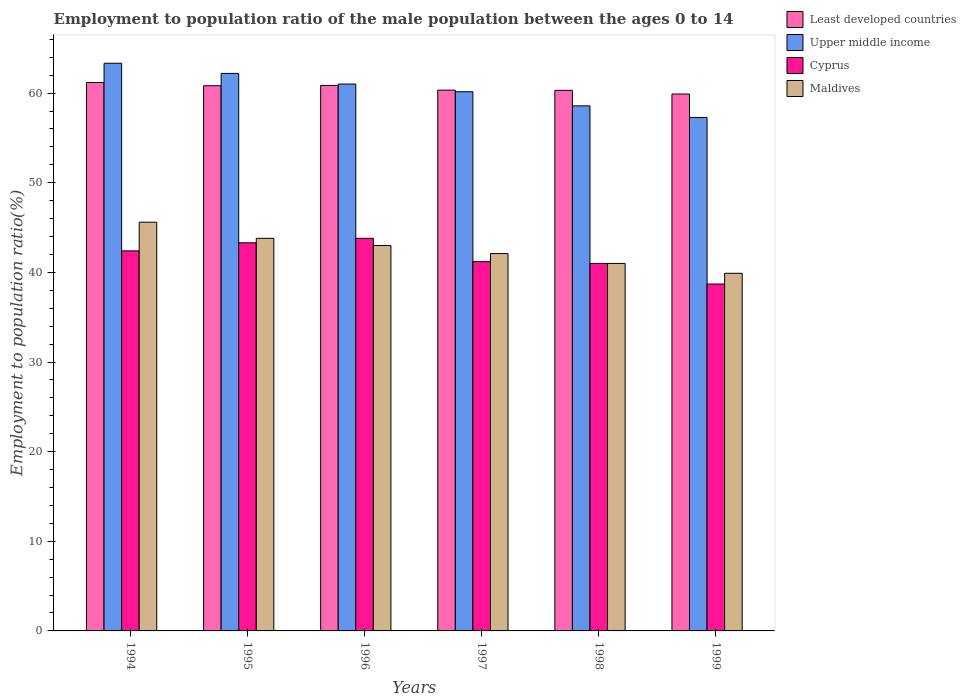How many groups of bars are there?
Provide a succinct answer. 6. How many bars are there on the 6th tick from the right?
Your answer should be compact. 4. What is the label of the 6th group of bars from the left?
Keep it short and to the point. 1999. What is the employment to population ratio in Maldives in 1998?
Ensure brevity in your answer.  41. Across all years, what is the maximum employment to population ratio in Upper middle income?
Offer a terse response. 63.33. Across all years, what is the minimum employment to population ratio in Cyprus?
Your response must be concise. 38.7. In which year was the employment to population ratio in Cyprus minimum?
Offer a very short reply. 1999. What is the total employment to population ratio in Maldives in the graph?
Provide a short and direct response. 255.4. What is the difference between the employment to population ratio in Least developed countries in 1994 and that in 1995?
Provide a short and direct response. 0.36. What is the difference between the employment to population ratio in Upper middle income in 1996 and the employment to population ratio in Least developed countries in 1994?
Offer a very short reply. -0.17. What is the average employment to population ratio in Least developed countries per year?
Provide a short and direct response. 60.57. In the year 1998, what is the difference between the employment to population ratio in Upper middle income and employment to population ratio in Least developed countries?
Your answer should be very brief. -1.73. In how many years, is the employment to population ratio in Least developed countries greater than 54 %?
Your response must be concise. 6. What is the ratio of the employment to population ratio in Upper middle income in 1994 to that in 1999?
Give a very brief answer. 1.11. Is the employment to population ratio in Maldives in 1994 less than that in 1995?
Make the answer very short. No. What is the difference between the highest and the second highest employment to population ratio in Upper middle income?
Give a very brief answer. 1.13. What is the difference between the highest and the lowest employment to population ratio in Upper middle income?
Your answer should be very brief. 6.04. Is the sum of the employment to population ratio in Cyprus in 1994 and 1999 greater than the maximum employment to population ratio in Least developed countries across all years?
Give a very brief answer. Yes. Is it the case that in every year, the sum of the employment to population ratio in Maldives and employment to population ratio in Least developed countries is greater than the sum of employment to population ratio in Upper middle income and employment to population ratio in Cyprus?
Provide a succinct answer. No. What does the 1st bar from the left in 1998 represents?
Ensure brevity in your answer.  Least developed countries. What does the 4th bar from the right in 1999 represents?
Your answer should be compact. Least developed countries. Are all the bars in the graph horizontal?
Offer a terse response. No. How many years are there in the graph?
Provide a succinct answer. 6. Does the graph contain grids?
Give a very brief answer. No. How are the legend labels stacked?
Provide a succinct answer. Vertical. What is the title of the graph?
Give a very brief answer. Employment to population ratio of the male population between the ages 0 to 14. Does "San Marino" appear as one of the legend labels in the graph?
Ensure brevity in your answer.  No. What is the label or title of the X-axis?
Offer a very short reply. Years. What is the Employment to population ratio(%) in Least developed countries in 1994?
Offer a very short reply. 61.18. What is the Employment to population ratio(%) in Upper middle income in 1994?
Give a very brief answer. 63.33. What is the Employment to population ratio(%) in Cyprus in 1994?
Your response must be concise. 42.4. What is the Employment to population ratio(%) of Maldives in 1994?
Your answer should be very brief. 45.6. What is the Employment to population ratio(%) of Least developed countries in 1995?
Offer a terse response. 60.82. What is the Employment to population ratio(%) of Upper middle income in 1995?
Provide a short and direct response. 62.2. What is the Employment to population ratio(%) of Cyprus in 1995?
Provide a short and direct response. 43.3. What is the Employment to population ratio(%) of Maldives in 1995?
Give a very brief answer. 43.8. What is the Employment to population ratio(%) of Least developed countries in 1996?
Your response must be concise. 60.86. What is the Employment to population ratio(%) in Upper middle income in 1996?
Offer a very short reply. 61.01. What is the Employment to population ratio(%) of Cyprus in 1996?
Keep it short and to the point. 43.8. What is the Employment to population ratio(%) of Least developed countries in 1997?
Provide a succinct answer. 60.33. What is the Employment to population ratio(%) of Upper middle income in 1997?
Offer a very short reply. 60.15. What is the Employment to population ratio(%) in Cyprus in 1997?
Offer a terse response. 41.2. What is the Employment to population ratio(%) in Maldives in 1997?
Offer a terse response. 42.1. What is the Employment to population ratio(%) in Least developed countries in 1998?
Your response must be concise. 60.31. What is the Employment to population ratio(%) in Upper middle income in 1998?
Provide a short and direct response. 58.58. What is the Employment to population ratio(%) of Cyprus in 1998?
Your response must be concise. 41. What is the Employment to population ratio(%) in Least developed countries in 1999?
Your response must be concise. 59.9. What is the Employment to population ratio(%) in Upper middle income in 1999?
Keep it short and to the point. 57.29. What is the Employment to population ratio(%) in Cyprus in 1999?
Your answer should be very brief. 38.7. What is the Employment to population ratio(%) in Maldives in 1999?
Offer a terse response. 39.9. Across all years, what is the maximum Employment to population ratio(%) in Least developed countries?
Keep it short and to the point. 61.18. Across all years, what is the maximum Employment to population ratio(%) of Upper middle income?
Offer a terse response. 63.33. Across all years, what is the maximum Employment to population ratio(%) in Cyprus?
Provide a short and direct response. 43.8. Across all years, what is the maximum Employment to population ratio(%) in Maldives?
Your answer should be compact. 45.6. Across all years, what is the minimum Employment to population ratio(%) of Least developed countries?
Offer a terse response. 59.9. Across all years, what is the minimum Employment to population ratio(%) in Upper middle income?
Keep it short and to the point. 57.29. Across all years, what is the minimum Employment to population ratio(%) in Cyprus?
Provide a succinct answer. 38.7. Across all years, what is the minimum Employment to population ratio(%) of Maldives?
Offer a terse response. 39.9. What is the total Employment to population ratio(%) of Least developed countries in the graph?
Provide a succinct answer. 363.41. What is the total Employment to population ratio(%) in Upper middle income in the graph?
Your answer should be compact. 362.56. What is the total Employment to population ratio(%) of Cyprus in the graph?
Your answer should be very brief. 250.4. What is the total Employment to population ratio(%) in Maldives in the graph?
Ensure brevity in your answer.  255.4. What is the difference between the Employment to population ratio(%) in Least developed countries in 1994 and that in 1995?
Make the answer very short. 0.36. What is the difference between the Employment to population ratio(%) in Upper middle income in 1994 and that in 1995?
Your response must be concise. 1.13. What is the difference between the Employment to population ratio(%) in Maldives in 1994 and that in 1995?
Offer a very short reply. 1.8. What is the difference between the Employment to population ratio(%) in Least developed countries in 1994 and that in 1996?
Your answer should be compact. 0.32. What is the difference between the Employment to population ratio(%) of Upper middle income in 1994 and that in 1996?
Provide a succinct answer. 2.32. What is the difference between the Employment to population ratio(%) of Cyprus in 1994 and that in 1996?
Provide a short and direct response. -1.4. What is the difference between the Employment to population ratio(%) of Maldives in 1994 and that in 1996?
Provide a short and direct response. 2.6. What is the difference between the Employment to population ratio(%) in Least developed countries in 1994 and that in 1997?
Offer a terse response. 0.85. What is the difference between the Employment to population ratio(%) in Upper middle income in 1994 and that in 1997?
Ensure brevity in your answer.  3.18. What is the difference between the Employment to population ratio(%) in Least developed countries in 1994 and that in 1998?
Your response must be concise. 0.87. What is the difference between the Employment to population ratio(%) in Upper middle income in 1994 and that in 1998?
Offer a terse response. 4.75. What is the difference between the Employment to population ratio(%) in Cyprus in 1994 and that in 1998?
Make the answer very short. 1.4. What is the difference between the Employment to population ratio(%) of Maldives in 1994 and that in 1998?
Give a very brief answer. 4.6. What is the difference between the Employment to population ratio(%) in Least developed countries in 1994 and that in 1999?
Provide a succinct answer. 1.28. What is the difference between the Employment to population ratio(%) in Upper middle income in 1994 and that in 1999?
Keep it short and to the point. 6.04. What is the difference between the Employment to population ratio(%) in Maldives in 1994 and that in 1999?
Provide a succinct answer. 5.7. What is the difference between the Employment to population ratio(%) in Least developed countries in 1995 and that in 1996?
Your response must be concise. -0.04. What is the difference between the Employment to population ratio(%) of Upper middle income in 1995 and that in 1996?
Give a very brief answer. 1.19. What is the difference between the Employment to population ratio(%) in Cyprus in 1995 and that in 1996?
Make the answer very short. -0.5. What is the difference between the Employment to population ratio(%) of Least developed countries in 1995 and that in 1997?
Your answer should be compact. 0.49. What is the difference between the Employment to population ratio(%) in Upper middle income in 1995 and that in 1997?
Your answer should be compact. 2.05. What is the difference between the Employment to population ratio(%) in Cyprus in 1995 and that in 1997?
Offer a terse response. 2.1. What is the difference between the Employment to population ratio(%) of Least developed countries in 1995 and that in 1998?
Make the answer very short. 0.51. What is the difference between the Employment to population ratio(%) of Upper middle income in 1995 and that in 1998?
Give a very brief answer. 3.62. What is the difference between the Employment to population ratio(%) of Least developed countries in 1995 and that in 1999?
Your response must be concise. 0.92. What is the difference between the Employment to population ratio(%) in Upper middle income in 1995 and that in 1999?
Your answer should be compact. 4.91. What is the difference between the Employment to population ratio(%) in Cyprus in 1995 and that in 1999?
Your answer should be compact. 4.6. What is the difference between the Employment to population ratio(%) in Least developed countries in 1996 and that in 1997?
Make the answer very short. 0.53. What is the difference between the Employment to population ratio(%) in Upper middle income in 1996 and that in 1997?
Provide a short and direct response. 0.86. What is the difference between the Employment to population ratio(%) of Least developed countries in 1996 and that in 1998?
Keep it short and to the point. 0.55. What is the difference between the Employment to population ratio(%) of Upper middle income in 1996 and that in 1998?
Provide a short and direct response. 2.43. What is the difference between the Employment to population ratio(%) in Cyprus in 1996 and that in 1998?
Offer a very short reply. 2.8. What is the difference between the Employment to population ratio(%) of Least developed countries in 1996 and that in 1999?
Ensure brevity in your answer.  0.96. What is the difference between the Employment to population ratio(%) in Upper middle income in 1996 and that in 1999?
Give a very brief answer. 3.73. What is the difference between the Employment to population ratio(%) of Cyprus in 1996 and that in 1999?
Give a very brief answer. 5.1. What is the difference between the Employment to population ratio(%) in Maldives in 1996 and that in 1999?
Give a very brief answer. 3.1. What is the difference between the Employment to population ratio(%) of Least developed countries in 1997 and that in 1998?
Your answer should be compact. 0.02. What is the difference between the Employment to population ratio(%) in Upper middle income in 1997 and that in 1998?
Offer a terse response. 1.57. What is the difference between the Employment to population ratio(%) in Maldives in 1997 and that in 1998?
Your response must be concise. 1.1. What is the difference between the Employment to population ratio(%) in Least developed countries in 1997 and that in 1999?
Provide a succinct answer. 0.43. What is the difference between the Employment to population ratio(%) of Upper middle income in 1997 and that in 1999?
Make the answer very short. 2.86. What is the difference between the Employment to population ratio(%) of Maldives in 1997 and that in 1999?
Provide a succinct answer. 2.2. What is the difference between the Employment to population ratio(%) in Least developed countries in 1998 and that in 1999?
Make the answer very short. 0.41. What is the difference between the Employment to population ratio(%) in Upper middle income in 1998 and that in 1999?
Offer a terse response. 1.29. What is the difference between the Employment to population ratio(%) in Maldives in 1998 and that in 1999?
Provide a succinct answer. 1.1. What is the difference between the Employment to population ratio(%) of Least developed countries in 1994 and the Employment to population ratio(%) of Upper middle income in 1995?
Offer a very short reply. -1.02. What is the difference between the Employment to population ratio(%) of Least developed countries in 1994 and the Employment to population ratio(%) of Cyprus in 1995?
Offer a terse response. 17.88. What is the difference between the Employment to population ratio(%) in Least developed countries in 1994 and the Employment to population ratio(%) in Maldives in 1995?
Provide a succinct answer. 17.38. What is the difference between the Employment to population ratio(%) of Upper middle income in 1994 and the Employment to population ratio(%) of Cyprus in 1995?
Provide a succinct answer. 20.03. What is the difference between the Employment to population ratio(%) of Upper middle income in 1994 and the Employment to population ratio(%) of Maldives in 1995?
Your answer should be very brief. 19.53. What is the difference between the Employment to population ratio(%) of Least developed countries in 1994 and the Employment to population ratio(%) of Cyprus in 1996?
Your answer should be compact. 17.38. What is the difference between the Employment to population ratio(%) in Least developed countries in 1994 and the Employment to population ratio(%) in Maldives in 1996?
Your response must be concise. 18.18. What is the difference between the Employment to population ratio(%) of Upper middle income in 1994 and the Employment to population ratio(%) of Cyprus in 1996?
Give a very brief answer. 19.53. What is the difference between the Employment to population ratio(%) of Upper middle income in 1994 and the Employment to population ratio(%) of Maldives in 1996?
Keep it short and to the point. 20.33. What is the difference between the Employment to population ratio(%) in Least developed countries in 1994 and the Employment to population ratio(%) in Upper middle income in 1997?
Make the answer very short. 1.03. What is the difference between the Employment to population ratio(%) of Least developed countries in 1994 and the Employment to population ratio(%) of Cyprus in 1997?
Offer a very short reply. 19.98. What is the difference between the Employment to population ratio(%) in Least developed countries in 1994 and the Employment to population ratio(%) in Maldives in 1997?
Your answer should be very brief. 19.08. What is the difference between the Employment to population ratio(%) in Upper middle income in 1994 and the Employment to population ratio(%) in Cyprus in 1997?
Give a very brief answer. 22.13. What is the difference between the Employment to population ratio(%) of Upper middle income in 1994 and the Employment to population ratio(%) of Maldives in 1997?
Your answer should be very brief. 21.23. What is the difference between the Employment to population ratio(%) in Least developed countries in 1994 and the Employment to population ratio(%) in Upper middle income in 1998?
Make the answer very short. 2.6. What is the difference between the Employment to population ratio(%) in Least developed countries in 1994 and the Employment to population ratio(%) in Cyprus in 1998?
Make the answer very short. 20.18. What is the difference between the Employment to population ratio(%) of Least developed countries in 1994 and the Employment to population ratio(%) of Maldives in 1998?
Offer a very short reply. 20.18. What is the difference between the Employment to population ratio(%) in Upper middle income in 1994 and the Employment to population ratio(%) in Cyprus in 1998?
Provide a succinct answer. 22.33. What is the difference between the Employment to population ratio(%) in Upper middle income in 1994 and the Employment to population ratio(%) in Maldives in 1998?
Your answer should be very brief. 22.33. What is the difference between the Employment to population ratio(%) in Least developed countries in 1994 and the Employment to population ratio(%) in Upper middle income in 1999?
Offer a terse response. 3.89. What is the difference between the Employment to population ratio(%) in Least developed countries in 1994 and the Employment to population ratio(%) in Cyprus in 1999?
Give a very brief answer. 22.48. What is the difference between the Employment to population ratio(%) in Least developed countries in 1994 and the Employment to population ratio(%) in Maldives in 1999?
Provide a short and direct response. 21.28. What is the difference between the Employment to population ratio(%) in Upper middle income in 1994 and the Employment to population ratio(%) in Cyprus in 1999?
Offer a terse response. 24.63. What is the difference between the Employment to population ratio(%) in Upper middle income in 1994 and the Employment to population ratio(%) in Maldives in 1999?
Ensure brevity in your answer.  23.43. What is the difference between the Employment to population ratio(%) in Least developed countries in 1995 and the Employment to population ratio(%) in Upper middle income in 1996?
Give a very brief answer. -0.19. What is the difference between the Employment to population ratio(%) of Least developed countries in 1995 and the Employment to population ratio(%) of Cyprus in 1996?
Your answer should be compact. 17.02. What is the difference between the Employment to population ratio(%) of Least developed countries in 1995 and the Employment to population ratio(%) of Maldives in 1996?
Your answer should be very brief. 17.82. What is the difference between the Employment to population ratio(%) of Upper middle income in 1995 and the Employment to population ratio(%) of Cyprus in 1996?
Your response must be concise. 18.4. What is the difference between the Employment to population ratio(%) in Upper middle income in 1995 and the Employment to population ratio(%) in Maldives in 1996?
Your response must be concise. 19.2. What is the difference between the Employment to population ratio(%) in Cyprus in 1995 and the Employment to population ratio(%) in Maldives in 1996?
Offer a terse response. 0.3. What is the difference between the Employment to population ratio(%) of Least developed countries in 1995 and the Employment to population ratio(%) of Upper middle income in 1997?
Your answer should be very brief. 0.67. What is the difference between the Employment to population ratio(%) of Least developed countries in 1995 and the Employment to population ratio(%) of Cyprus in 1997?
Give a very brief answer. 19.62. What is the difference between the Employment to population ratio(%) in Least developed countries in 1995 and the Employment to population ratio(%) in Maldives in 1997?
Ensure brevity in your answer.  18.72. What is the difference between the Employment to population ratio(%) in Upper middle income in 1995 and the Employment to population ratio(%) in Cyprus in 1997?
Give a very brief answer. 21. What is the difference between the Employment to population ratio(%) in Upper middle income in 1995 and the Employment to population ratio(%) in Maldives in 1997?
Make the answer very short. 20.1. What is the difference between the Employment to population ratio(%) of Least developed countries in 1995 and the Employment to population ratio(%) of Upper middle income in 1998?
Your answer should be compact. 2.24. What is the difference between the Employment to population ratio(%) in Least developed countries in 1995 and the Employment to population ratio(%) in Cyprus in 1998?
Provide a short and direct response. 19.82. What is the difference between the Employment to population ratio(%) in Least developed countries in 1995 and the Employment to population ratio(%) in Maldives in 1998?
Offer a very short reply. 19.82. What is the difference between the Employment to population ratio(%) in Upper middle income in 1995 and the Employment to population ratio(%) in Cyprus in 1998?
Keep it short and to the point. 21.2. What is the difference between the Employment to population ratio(%) of Upper middle income in 1995 and the Employment to population ratio(%) of Maldives in 1998?
Provide a succinct answer. 21.2. What is the difference between the Employment to population ratio(%) in Cyprus in 1995 and the Employment to population ratio(%) in Maldives in 1998?
Offer a terse response. 2.3. What is the difference between the Employment to population ratio(%) of Least developed countries in 1995 and the Employment to population ratio(%) of Upper middle income in 1999?
Make the answer very short. 3.54. What is the difference between the Employment to population ratio(%) in Least developed countries in 1995 and the Employment to population ratio(%) in Cyprus in 1999?
Provide a succinct answer. 22.12. What is the difference between the Employment to population ratio(%) in Least developed countries in 1995 and the Employment to population ratio(%) in Maldives in 1999?
Give a very brief answer. 20.92. What is the difference between the Employment to population ratio(%) of Upper middle income in 1995 and the Employment to population ratio(%) of Cyprus in 1999?
Give a very brief answer. 23.5. What is the difference between the Employment to population ratio(%) in Upper middle income in 1995 and the Employment to population ratio(%) in Maldives in 1999?
Make the answer very short. 22.3. What is the difference between the Employment to population ratio(%) of Least developed countries in 1996 and the Employment to population ratio(%) of Upper middle income in 1997?
Offer a very short reply. 0.71. What is the difference between the Employment to population ratio(%) in Least developed countries in 1996 and the Employment to population ratio(%) in Cyprus in 1997?
Make the answer very short. 19.66. What is the difference between the Employment to population ratio(%) in Least developed countries in 1996 and the Employment to population ratio(%) in Maldives in 1997?
Your response must be concise. 18.76. What is the difference between the Employment to population ratio(%) in Upper middle income in 1996 and the Employment to population ratio(%) in Cyprus in 1997?
Your answer should be very brief. 19.81. What is the difference between the Employment to population ratio(%) in Upper middle income in 1996 and the Employment to population ratio(%) in Maldives in 1997?
Your response must be concise. 18.91. What is the difference between the Employment to population ratio(%) of Cyprus in 1996 and the Employment to population ratio(%) of Maldives in 1997?
Provide a succinct answer. 1.7. What is the difference between the Employment to population ratio(%) in Least developed countries in 1996 and the Employment to population ratio(%) in Upper middle income in 1998?
Give a very brief answer. 2.28. What is the difference between the Employment to population ratio(%) in Least developed countries in 1996 and the Employment to population ratio(%) in Cyprus in 1998?
Ensure brevity in your answer.  19.86. What is the difference between the Employment to population ratio(%) of Least developed countries in 1996 and the Employment to population ratio(%) of Maldives in 1998?
Your answer should be compact. 19.86. What is the difference between the Employment to population ratio(%) in Upper middle income in 1996 and the Employment to population ratio(%) in Cyprus in 1998?
Offer a terse response. 20.01. What is the difference between the Employment to population ratio(%) in Upper middle income in 1996 and the Employment to population ratio(%) in Maldives in 1998?
Offer a very short reply. 20.01. What is the difference between the Employment to population ratio(%) of Least developed countries in 1996 and the Employment to population ratio(%) of Upper middle income in 1999?
Your answer should be very brief. 3.57. What is the difference between the Employment to population ratio(%) in Least developed countries in 1996 and the Employment to population ratio(%) in Cyprus in 1999?
Offer a very short reply. 22.16. What is the difference between the Employment to population ratio(%) in Least developed countries in 1996 and the Employment to population ratio(%) in Maldives in 1999?
Provide a short and direct response. 20.96. What is the difference between the Employment to population ratio(%) of Upper middle income in 1996 and the Employment to population ratio(%) of Cyprus in 1999?
Your answer should be very brief. 22.31. What is the difference between the Employment to population ratio(%) in Upper middle income in 1996 and the Employment to population ratio(%) in Maldives in 1999?
Give a very brief answer. 21.11. What is the difference between the Employment to population ratio(%) of Least developed countries in 1997 and the Employment to population ratio(%) of Upper middle income in 1998?
Provide a short and direct response. 1.75. What is the difference between the Employment to population ratio(%) of Least developed countries in 1997 and the Employment to population ratio(%) of Cyprus in 1998?
Your response must be concise. 19.33. What is the difference between the Employment to population ratio(%) in Least developed countries in 1997 and the Employment to population ratio(%) in Maldives in 1998?
Make the answer very short. 19.33. What is the difference between the Employment to population ratio(%) in Upper middle income in 1997 and the Employment to population ratio(%) in Cyprus in 1998?
Provide a succinct answer. 19.15. What is the difference between the Employment to population ratio(%) in Upper middle income in 1997 and the Employment to population ratio(%) in Maldives in 1998?
Provide a succinct answer. 19.15. What is the difference between the Employment to population ratio(%) of Cyprus in 1997 and the Employment to population ratio(%) of Maldives in 1998?
Your answer should be compact. 0.2. What is the difference between the Employment to population ratio(%) in Least developed countries in 1997 and the Employment to population ratio(%) in Upper middle income in 1999?
Your answer should be compact. 3.05. What is the difference between the Employment to population ratio(%) of Least developed countries in 1997 and the Employment to population ratio(%) of Cyprus in 1999?
Your answer should be very brief. 21.63. What is the difference between the Employment to population ratio(%) in Least developed countries in 1997 and the Employment to population ratio(%) in Maldives in 1999?
Keep it short and to the point. 20.43. What is the difference between the Employment to population ratio(%) in Upper middle income in 1997 and the Employment to population ratio(%) in Cyprus in 1999?
Give a very brief answer. 21.45. What is the difference between the Employment to population ratio(%) in Upper middle income in 1997 and the Employment to population ratio(%) in Maldives in 1999?
Provide a succinct answer. 20.25. What is the difference between the Employment to population ratio(%) in Cyprus in 1997 and the Employment to population ratio(%) in Maldives in 1999?
Keep it short and to the point. 1.3. What is the difference between the Employment to population ratio(%) in Least developed countries in 1998 and the Employment to population ratio(%) in Upper middle income in 1999?
Your response must be concise. 3.02. What is the difference between the Employment to population ratio(%) of Least developed countries in 1998 and the Employment to population ratio(%) of Cyprus in 1999?
Offer a very short reply. 21.61. What is the difference between the Employment to population ratio(%) in Least developed countries in 1998 and the Employment to population ratio(%) in Maldives in 1999?
Make the answer very short. 20.41. What is the difference between the Employment to population ratio(%) in Upper middle income in 1998 and the Employment to population ratio(%) in Cyprus in 1999?
Make the answer very short. 19.88. What is the difference between the Employment to population ratio(%) in Upper middle income in 1998 and the Employment to population ratio(%) in Maldives in 1999?
Offer a very short reply. 18.68. What is the difference between the Employment to population ratio(%) of Cyprus in 1998 and the Employment to population ratio(%) of Maldives in 1999?
Provide a short and direct response. 1.1. What is the average Employment to population ratio(%) of Least developed countries per year?
Give a very brief answer. 60.57. What is the average Employment to population ratio(%) in Upper middle income per year?
Offer a very short reply. 60.43. What is the average Employment to population ratio(%) of Cyprus per year?
Keep it short and to the point. 41.73. What is the average Employment to population ratio(%) of Maldives per year?
Your answer should be compact. 42.57. In the year 1994, what is the difference between the Employment to population ratio(%) of Least developed countries and Employment to population ratio(%) of Upper middle income?
Your response must be concise. -2.15. In the year 1994, what is the difference between the Employment to population ratio(%) of Least developed countries and Employment to population ratio(%) of Cyprus?
Offer a terse response. 18.78. In the year 1994, what is the difference between the Employment to population ratio(%) in Least developed countries and Employment to population ratio(%) in Maldives?
Your answer should be compact. 15.58. In the year 1994, what is the difference between the Employment to population ratio(%) of Upper middle income and Employment to population ratio(%) of Cyprus?
Provide a succinct answer. 20.93. In the year 1994, what is the difference between the Employment to population ratio(%) in Upper middle income and Employment to population ratio(%) in Maldives?
Make the answer very short. 17.73. In the year 1994, what is the difference between the Employment to population ratio(%) in Cyprus and Employment to population ratio(%) in Maldives?
Offer a terse response. -3.2. In the year 1995, what is the difference between the Employment to population ratio(%) of Least developed countries and Employment to population ratio(%) of Upper middle income?
Ensure brevity in your answer.  -1.38. In the year 1995, what is the difference between the Employment to population ratio(%) in Least developed countries and Employment to population ratio(%) in Cyprus?
Your response must be concise. 17.52. In the year 1995, what is the difference between the Employment to population ratio(%) in Least developed countries and Employment to population ratio(%) in Maldives?
Ensure brevity in your answer.  17.02. In the year 1995, what is the difference between the Employment to population ratio(%) in Upper middle income and Employment to population ratio(%) in Cyprus?
Keep it short and to the point. 18.9. In the year 1995, what is the difference between the Employment to population ratio(%) in Upper middle income and Employment to population ratio(%) in Maldives?
Keep it short and to the point. 18.4. In the year 1995, what is the difference between the Employment to population ratio(%) in Cyprus and Employment to population ratio(%) in Maldives?
Your response must be concise. -0.5. In the year 1996, what is the difference between the Employment to population ratio(%) of Least developed countries and Employment to population ratio(%) of Upper middle income?
Provide a succinct answer. -0.15. In the year 1996, what is the difference between the Employment to population ratio(%) of Least developed countries and Employment to population ratio(%) of Cyprus?
Provide a short and direct response. 17.06. In the year 1996, what is the difference between the Employment to population ratio(%) of Least developed countries and Employment to population ratio(%) of Maldives?
Keep it short and to the point. 17.86. In the year 1996, what is the difference between the Employment to population ratio(%) in Upper middle income and Employment to population ratio(%) in Cyprus?
Ensure brevity in your answer.  17.21. In the year 1996, what is the difference between the Employment to population ratio(%) in Upper middle income and Employment to population ratio(%) in Maldives?
Keep it short and to the point. 18.01. In the year 1996, what is the difference between the Employment to population ratio(%) in Cyprus and Employment to population ratio(%) in Maldives?
Provide a short and direct response. 0.8. In the year 1997, what is the difference between the Employment to population ratio(%) in Least developed countries and Employment to population ratio(%) in Upper middle income?
Your response must be concise. 0.18. In the year 1997, what is the difference between the Employment to population ratio(%) in Least developed countries and Employment to population ratio(%) in Cyprus?
Provide a short and direct response. 19.13. In the year 1997, what is the difference between the Employment to population ratio(%) in Least developed countries and Employment to population ratio(%) in Maldives?
Your response must be concise. 18.23. In the year 1997, what is the difference between the Employment to population ratio(%) of Upper middle income and Employment to population ratio(%) of Cyprus?
Give a very brief answer. 18.95. In the year 1997, what is the difference between the Employment to population ratio(%) of Upper middle income and Employment to population ratio(%) of Maldives?
Offer a terse response. 18.05. In the year 1997, what is the difference between the Employment to population ratio(%) in Cyprus and Employment to population ratio(%) in Maldives?
Keep it short and to the point. -0.9. In the year 1998, what is the difference between the Employment to population ratio(%) of Least developed countries and Employment to population ratio(%) of Upper middle income?
Your answer should be compact. 1.73. In the year 1998, what is the difference between the Employment to population ratio(%) in Least developed countries and Employment to population ratio(%) in Cyprus?
Your answer should be very brief. 19.31. In the year 1998, what is the difference between the Employment to population ratio(%) in Least developed countries and Employment to population ratio(%) in Maldives?
Provide a succinct answer. 19.31. In the year 1998, what is the difference between the Employment to population ratio(%) of Upper middle income and Employment to population ratio(%) of Cyprus?
Provide a short and direct response. 17.58. In the year 1998, what is the difference between the Employment to population ratio(%) of Upper middle income and Employment to population ratio(%) of Maldives?
Make the answer very short. 17.58. In the year 1998, what is the difference between the Employment to population ratio(%) of Cyprus and Employment to population ratio(%) of Maldives?
Ensure brevity in your answer.  0. In the year 1999, what is the difference between the Employment to population ratio(%) of Least developed countries and Employment to population ratio(%) of Upper middle income?
Keep it short and to the point. 2.61. In the year 1999, what is the difference between the Employment to population ratio(%) of Least developed countries and Employment to population ratio(%) of Cyprus?
Make the answer very short. 21.2. In the year 1999, what is the difference between the Employment to population ratio(%) in Least developed countries and Employment to population ratio(%) in Maldives?
Ensure brevity in your answer.  20. In the year 1999, what is the difference between the Employment to population ratio(%) in Upper middle income and Employment to population ratio(%) in Cyprus?
Offer a terse response. 18.59. In the year 1999, what is the difference between the Employment to population ratio(%) of Upper middle income and Employment to population ratio(%) of Maldives?
Keep it short and to the point. 17.39. What is the ratio of the Employment to population ratio(%) in Least developed countries in 1994 to that in 1995?
Your answer should be compact. 1.01. What is the ratio of the Employment to population ratio(%) in Upper middle income in 1994 to that in 1995?
Your response must be concise. 1.02. What is the ratio of the Employment to population ratio(%) in Cyprus in 1994 to that in 1995?
Offer a terse response. 0.98. What is the ratio of the Employment to population ratio(%) in Maldives in 1994 to that in 1995?
Your response must be concise. 1.04. What is the ratio of the Employment to population ratio(%) of Upper middle income in 1994 to that in 1996?
Give a very brief answer. 1.04. What is the ratio of the Employment to population ratio(%) in Cyprus in 1994 to that in 1996?
Ensure brevity in your answer.  0.97. What is the ratio of the Employment to population ratio(%) of Maldives in 1994 to that in 1996?
Provide a short and direct response. 1.06. What is the ratio of the Employment to population ratio(%) in Upper middle income in 1994 to that in 1997?
Your answer should be compact. 1.05. What is the ratio of the Employment to population ratio(%) in Cyprus in 1994 to that in 1997?
Provide a succinct answer. 1.03. What is the ratio of the Employment to population ratio(%) of Maldives in 1994 to that in 1997?
Your answer should be very brief. 1.08. What is the ratio of the Employment to population ratio(%) in Least developed countries in 1994 to that in 1998?
Provide a succinct answer. 1.01. What is the ratio of the Employment to population ratio(%) in Upper middle income in 1994 to that in 1998?
Ensure brevity in your answer.  1.08. What is the ratio of the Employment to population ratio(%) of Cyprus in 1994 to that in 1998?
Offer a very short reply. 1.03. What is the ratio of the Employment to population ratio(%) in Maldives in 1994 to that in 1998?
Make the answer very short. 1.11. What is the ratio of the Employment to population ratio(%) of Least developed countries in 1994 to that in 1999?
Your response must be concise. 1.02. What is the ratio of the Employment to population ratio(%) in Upper middle income in 1994 to that in 1999?
Ensure brevity in your answer.  1.11. What is the ratio of the Employment to population ratio(%) in Cyprus in 1994 to that in 1999?
Your answer should be compact. 1.1. What is the ratio of the Employment to population ratio(%) of Maldives in 1994 to that in 1999?
Make the answer very short. 1.14. What is the ratio of the Employment to population ratio(%) of Least developed countries in 1995 to that in 1996?
Provide a short and direct response. 1. What is the ratio of the Employment to population ratio(%) of Upper middle income in 1995 to that in 1996?
Make the answer very short. 1.02. What is the ratio of the Employment to population ratio(%) of Maldives in 1995 to that in 1996?
Give a very brief answer. 1.02. What is the ratio of the Employment to population ratio(%) of Upper middle income in 1995 to that in 1997?
Your response must be concise. 1.03. What is the ratio of the Employment to population ratio(%) in Cyprus in 1995 to that in 1997?
Give a very brief answer. 1.05. What is the ratio of the Employment to population ratio(%) of Maldives in 1995 to that in 1997?
Keep it short and to the point. 1.04. What is the ratio of the Employment to population ratio(%) of Least developed countries in 1995 to that in 1998?
Keep it short and to the point. 1.01. What is the ratio of the Employment to population ratio(%) in Upper middle income in 1995 to that in 1998?
Offer a terse response. 1.06. What is the ratio of the Employment to population ratio(%) of Cyprus in 1995 to that in 1998?
Provide a short and direct response. 1.06. What is the ratio of the Employment to population ratio(%) in Maldives in 1995 to that in 1998?
Your response must be concise. 1.07. What is the ratio of the Employment to population ratio(%) in Least developed countries in 1995 to that in 1999?
Give a very brief answer. 1.02. What is the ratio of the Employment to population ratio(%) of Upper middle income in 1995 to that in 1999?
Provide a succinct answer. 1.09. What is the ratio of the Employment to population ratio(%) of Cyprus in 1995 to that in 1999?
Provide a short and direct response. 1.12. What is the ratio of the Employment to population ratio(%) in Maldives in 1995 to that in 1999?
Your response must be concise. 1.1. What is the ratio of the Employment to population ratio(%) in Least developed countries in 1996 to that in 1997?
Offer a terse response. 1.01. What is the ratio of the Employment to population ratio(%) of Upper middle income in 1996 to that in 1997?
Your response must be concise. 1.01. What is the ratio of the Employment to population ratio(%) in Cyprus in 1996 to that in 1997?
Offer a terse response. 1.06. What is the ratio of the Employment to population ratio(%) in Maldives in 1996 to that in 1997?
Provide a short and direct response. 1.02. What is the ratio of the Employment to population ratio(%) in Least developed countries in 1996 to that in 1998?
Your answer should be compact. 1.01. What is the ratio of the Employment to population ratio(%) in Upper middle income in 1996 to that in 1998?
Your answer should be very brief. 1.04. What is the ratio of the Employment to population ratio(%) in Cyprus in 1996 to that in 1998?
Keep it short and to the point. 1.07. What is the ratio of the Employment to population ratio(%) of Maldives in 1996 to that in 1998?
Your answer should be compact. 1.05. What is the ratio of the Employment to population ratio(%) in Least developed countries in 1996 to that in 1999?
Your answer should be very brief. 1.02. What is the ratio of the Employment to population ratio(%) in Upper middle income in 1996 to that in 1999?
Offer a very short reply. 1.06. What is the ratio of the Employment to population ratio(%) of Cyprus in 1996 to that in 1999?
Make the answer very short. 1.13. What is the ratio of the Employment to population ratio(%) in Maldives in 1996 to that in 1999?
Keep it short and to the point. 1.08. What is the ratio of the Employment to population ratio(%) of Upper middle income in 1997 to that in 1998?
Your response must be concise. 1.03. What is the ratio of the Employment to population ratio(%) in Cyprus in 1997 to that in 1998?
Provide a short and direct response. 1. What is the ratio of the Employment to population ratio(%) in Maldives in 1997 to that in 1998?
Make the answer very short. 1.03. What is the ratio of the Employment to population ratio(%) of Least developed countries in 1997 to that in 1999?
Give a very brief answer. 1.01. What is the ratio of the Employment to population ratio(%) of Upper middle income in 1997 to that in 1999?
Offer a very short reply. 1.05. What is the ratio of the Employment to population ratio(%) in Cyprus in 1997 to that in 1999?
Keep it short and to the point. 1.06. What is the ratio of the Employment to population ratio(%) in Maldives in 1997 to that in 1999?
Keep it short and to the point. 1.06. What is the ratio of the Employment to population ratio(%) in Least developed countries in 1998 to that in 1999?
Keep it short and to the point. 1.01. What is the ratio of the Employment to population ratio(%) in Upper middle income in 1998 to that in 1999?
Your answer should be compact. 1.02. What is the ratio of the Employment to population ratio(%) in Cyprus in 1998 to that in 1999?
Provide a short and direct response. 1.06. What is the ratio of the Employment to population ratio(%) of Maldives in 1998 to that in 1999?
Ensure brevity in your answer.  1.03. What is the difference between the highest and the second highest Employment to population ratio(%) in Least developed countries?
Make the answer very short. 0.32. What is the difference between the highest and the second highest Employment to population ratio(%) in Upper middle income?
Your response must be concise. 1.13. What is the difference between the highest and the second highest Employment to population ratio(%) of Cyprus?
Make the answer very short. 0.5. What is the difference between the highest and the second highest Employment to population ratio(%) in Maldives?
Give a very brief answer. 1.8. What is the difference between the highest and the lowest Employment to population ratio(%) of Least developed countries?
Provide a succinct answer. 1.28. What is the difference between the highest and the lowest Employment to population ratio(%) in Upper middle income?
Offer a very short reply. 6.04. 